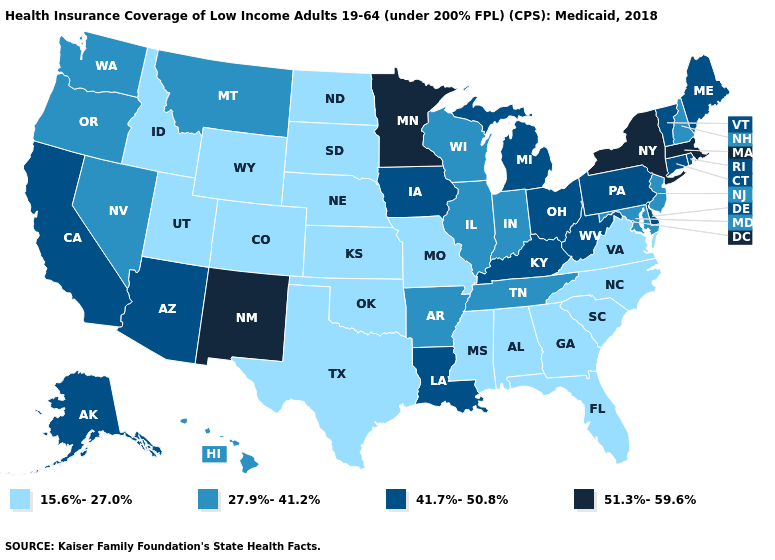What is the value of Hawaii?
Keep it brief. 27.9%-41.2%. Among the states that border Nevada , does Arizona have the highest value?
Concise answer only. Yes. What is the value of South Carolina?
Be succinct. 15.6%-27.0%. Does the map have missing data?
Answer briefly. No. Name the states that have a value in the range 51.3%-59.6%?
Keep it brief. Massachusetts, Minnesota, New Mexico, New York. What is the lowest value in the USA?
Write a very short answer. 15.6%-27.0%. Does Illinois have the lowest value in the USA?
Quick response, please. No. Name the states that have a value in the range 51.3%-59.6%?
Write a very short answer. Massachusetts, Minnesota, New Mexico, New York. Name the states that have a value in the range 27.9%-41.2%?
Write a very short answer. Arkansas, Hawaii, Illinois, Indiana, Maryland, Montana, Nevada, New Hampshire, New Jersey, Oregon, Tennessee, Washington, Wisconsin. How many symbols are there in the legend?
Concise answer only. 4. What is the value of Colorado?
Concise answer only. 15.6%-27.0%. Among the states that border New York , does Vermont have the lowest value?
Keep it brief. No. Is the legend a continuous bar?
Be succinct. No. Does the map have missing data?
Short answer required. No. Is the legend a continuous bar?
Concise answer only. No. 